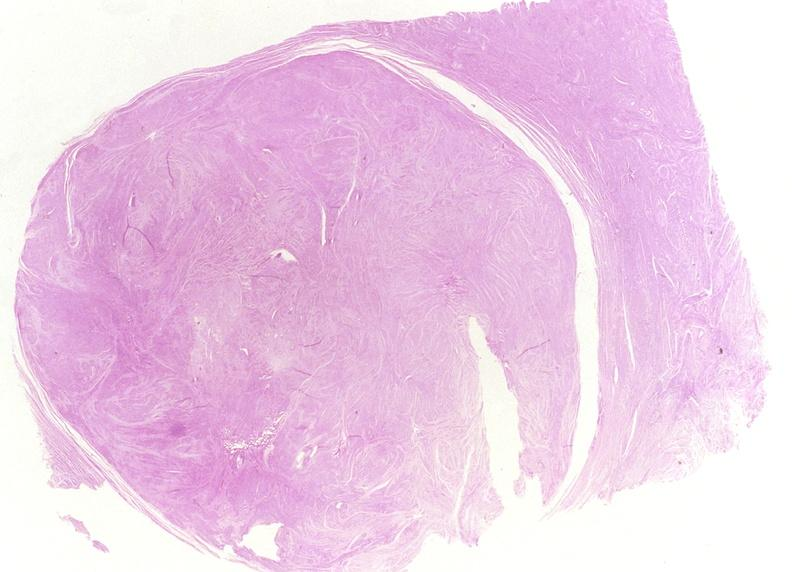where is this from?
Answer the question using a single word or phrase. Female reproductive system 